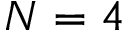Convert formula to latex. <formula><loc_0><loc_0><loc_500><loc_500>N = 4</formula> 